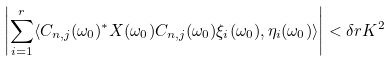<formula> <loc_0><loc_0><loc_500><loc_500>\left | \sum _ { i = 1 } ^ { r } \langle C _ { n , j } ( \omega _ { 0 } ) ^ { * } X ( \omega _ { 0 } ) C _ { n , j } ( \omega _ { 0 } ) \xi _ { i } ( \omega _ { 0 } ) , \eta _ { i } ( \omega _ { 0 } ) \rangle \right | < \delta r K ^ { 2 }</formula> 